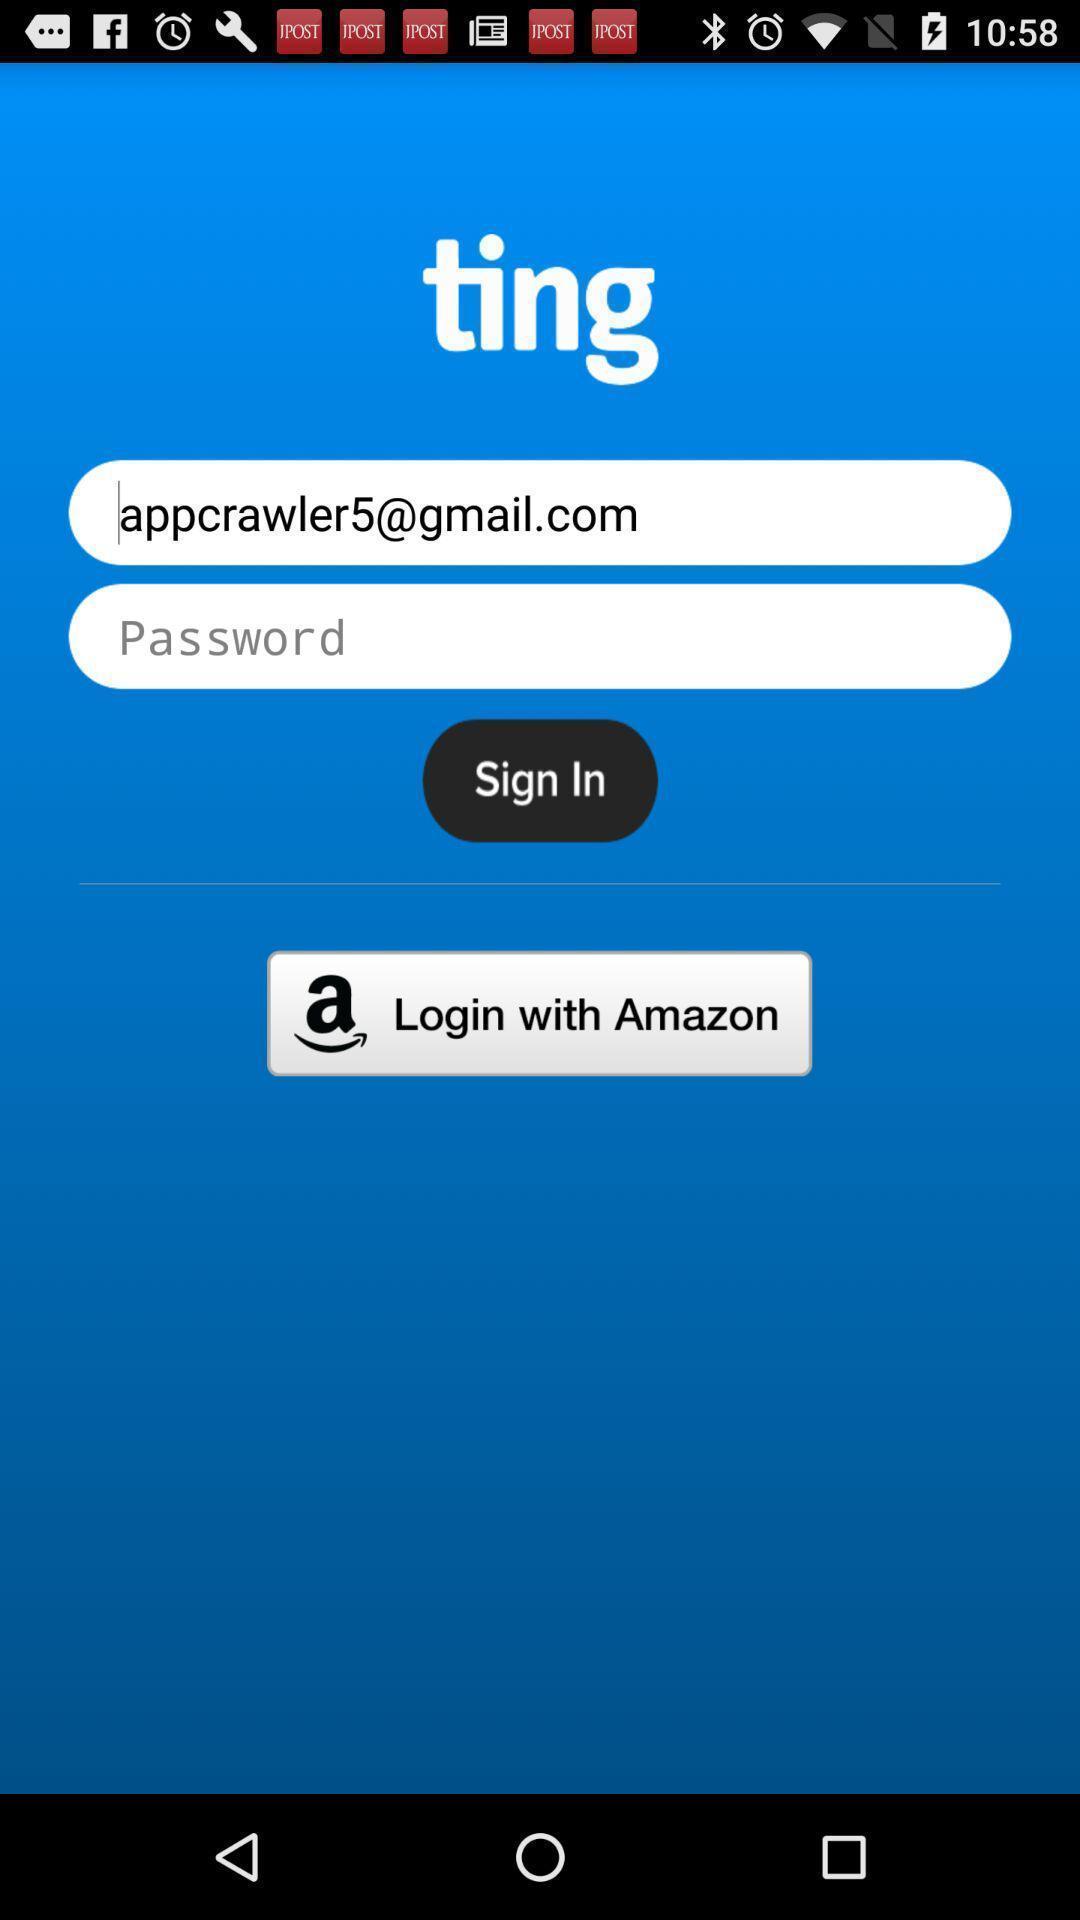Explain what's happening in this screen capture. Welcome page for an app. 